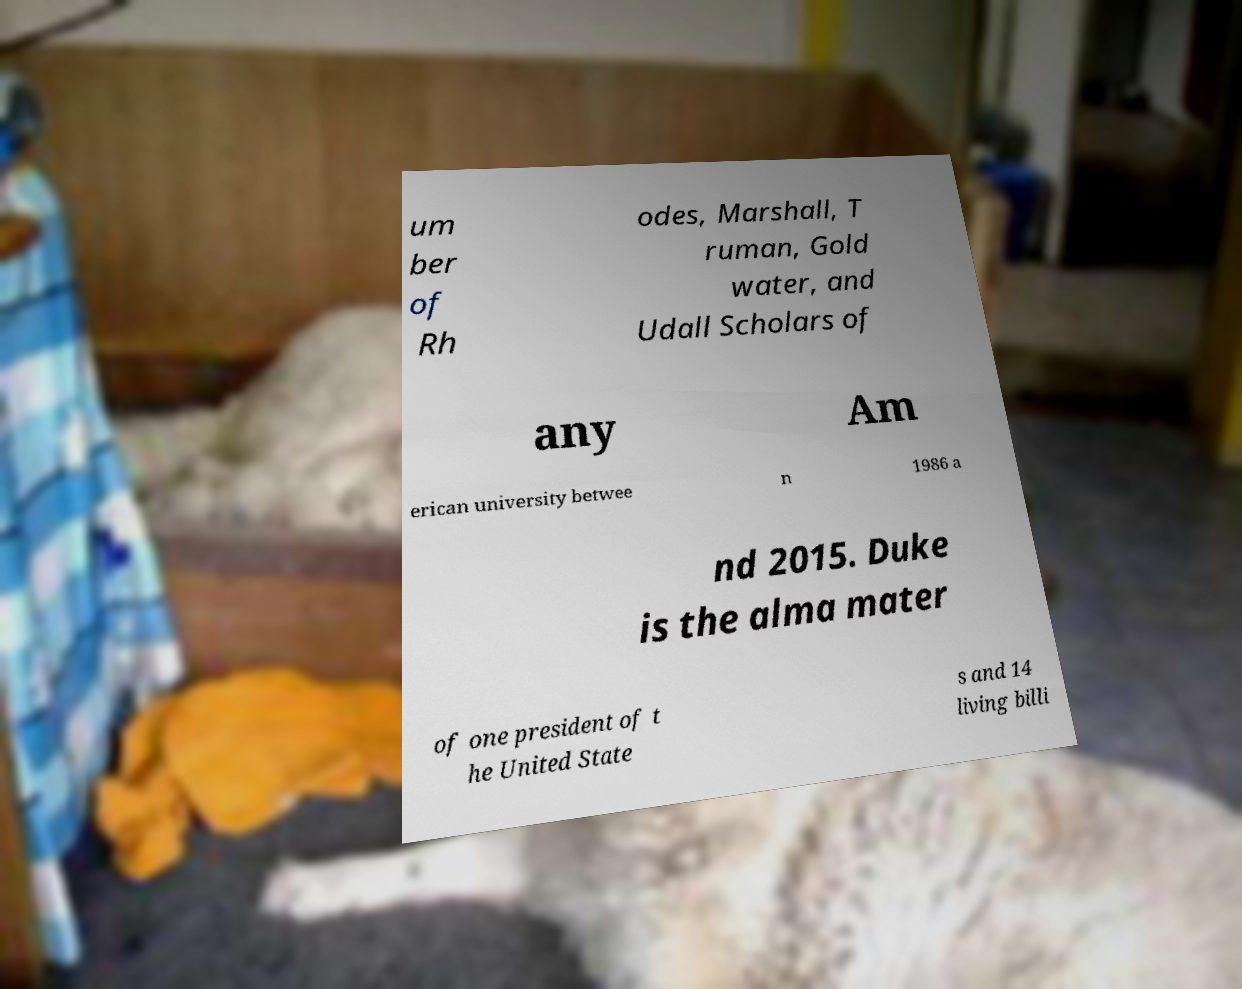Can you read and provide the text displayed in the image?This photo seems to have some interesting text. Can you extract and type it out for me? um ber of Rh odes, Marshall, T ruman, Gold water, and Udall Scholars of any Am erican university betwee n 1986 a nd 2015. Duke is the alma mater of one president of t he United State s and 14 living billi 